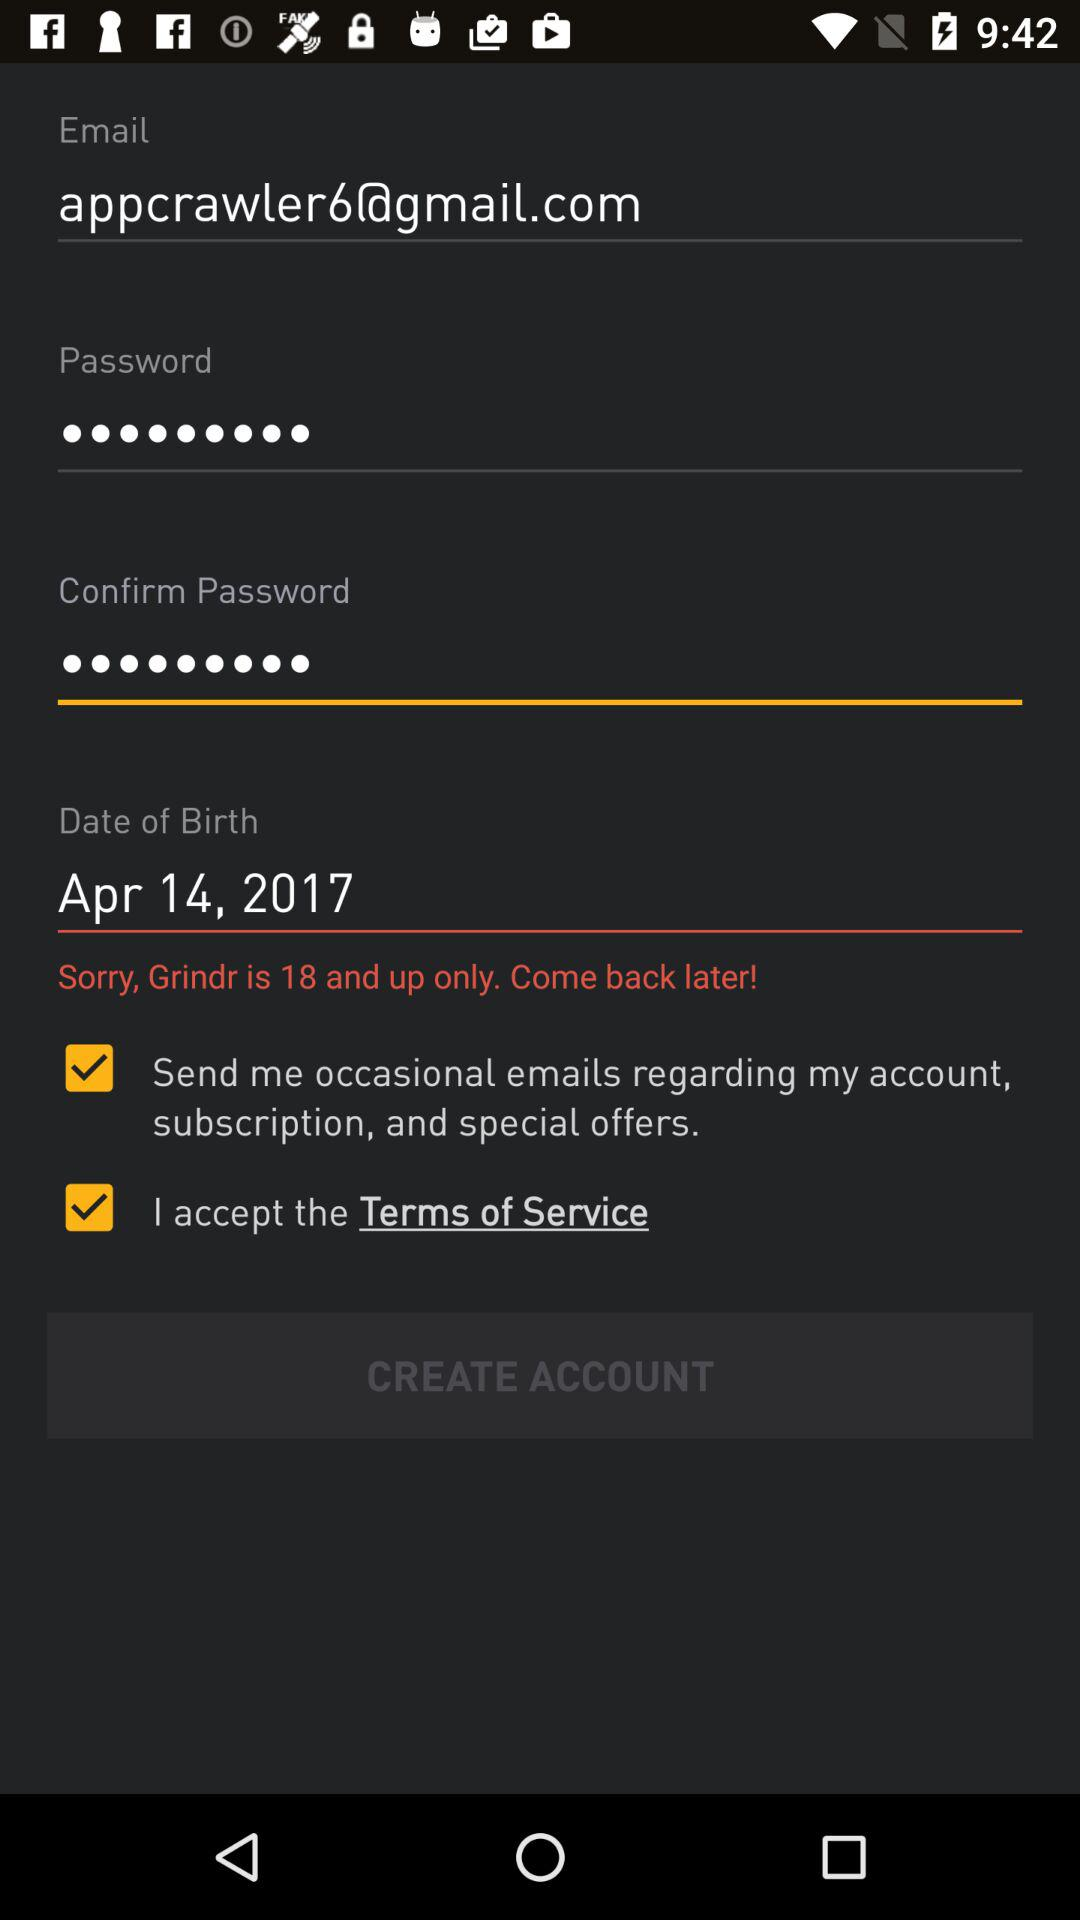What is the status of the option that includes acceptance to the “Terms of Service”? The status of the option that includes acceptance to the "Terms of Service" is "on". 